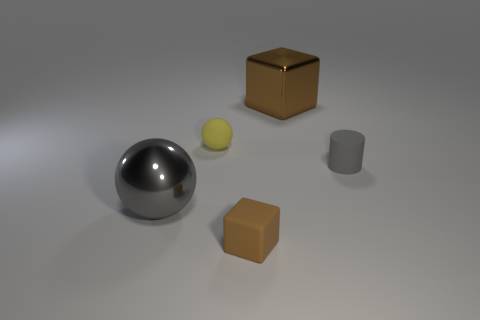Add 3 small red rubber cylinders. How many objects exist? 8 Subtract 1 balls. How many balls are left? 1 Subtract all yellow balls. How many balls are left? 1 Subtract all cubes. How many objects are left? 3 Subtract all yellow matte objects. Subtract all tiny blue rubber objects. How many objects are left? 4 Add 4 big brown cubes. How many big brown cubes are left? 5 Add 5 large spheres. How many large spheres exist? 6 Subtract 0 yellow cylinders. How many objects are left? 5 Subtract all green blocks. Subtract all brown cylinders. How many blocks are left? 2 